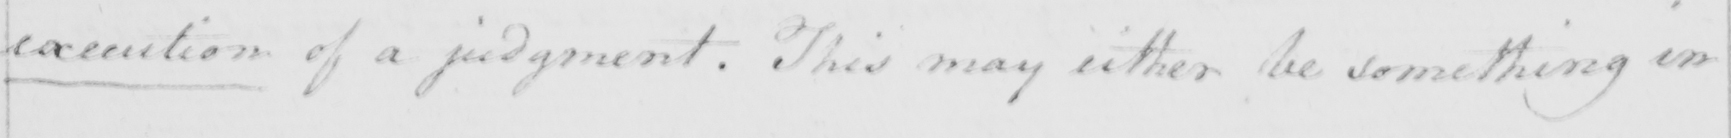Can you read and transcribe this handwriting? execution of a judgment . This may either be something in 